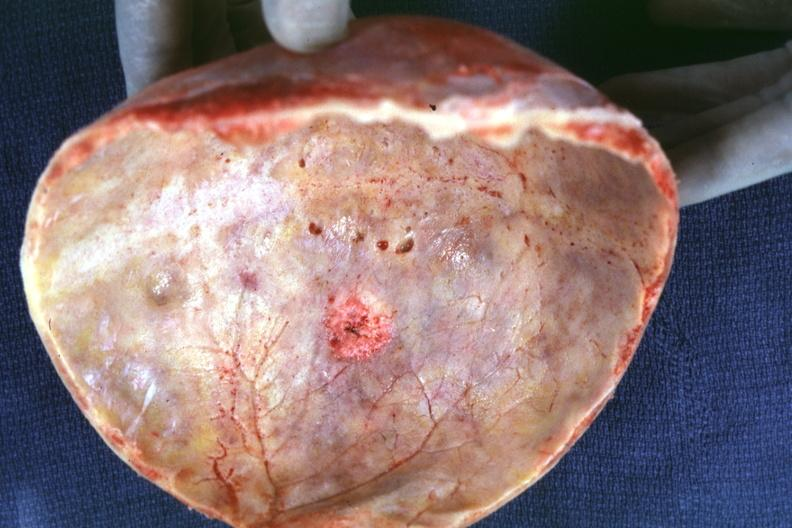does this image show skull cap with obvious metastatic lesion seen on inner table prostate primary?
Answer the question using a single word or phrase. Yes 